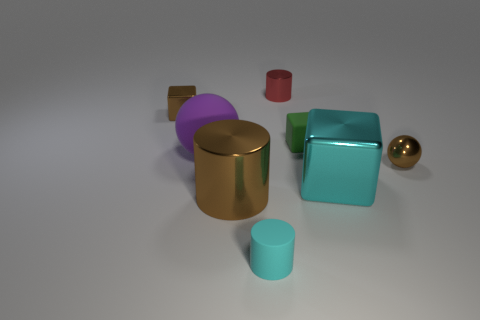Subtract 1 blocks. How many blocks are left? 2 Add 1 big cyan matte balls. How many objects exist? 9 Subtract all blocks. How many objects are left? 5 Add 7 cyan rubber cylinders. How many cyan rubber cylinders exist? 8 Subtract 0 blue cubes. How many objects are left? 8 Subtract all brown cylinders. Subtract all metallic objects. How many objects are left? 2 Add 2 big cylinders. How many big cylinders are left? 3 